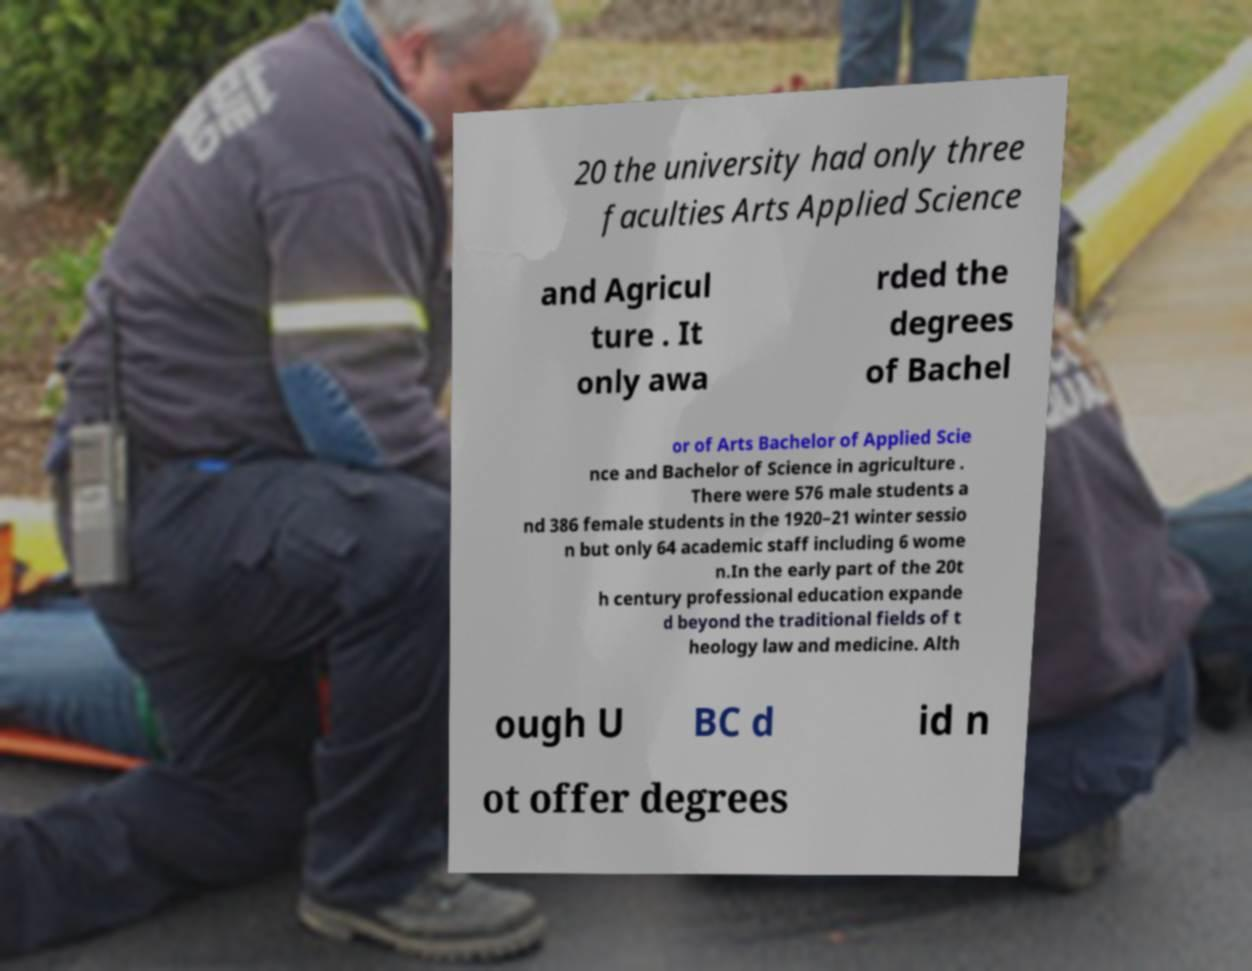For documentation purposes, I need the text within this image transcribed. Could you provide that? 20 the university had only three faculties Arts Applied Science and Agricul ture . It only awa rded the degrees of Bachel or of Arts Bachelor of Applied Scie nce and Bachelor of Science in agriculture . There were 576 male students a nd 386 female students in the 1920–21 winter sessio n but only 64 academic staff including 6 wome n.In the early part of the 20t h century professional education expande d beyond the traditional fields of t heology law and medicine. Alth ough U BC d id n ot offer degrees 